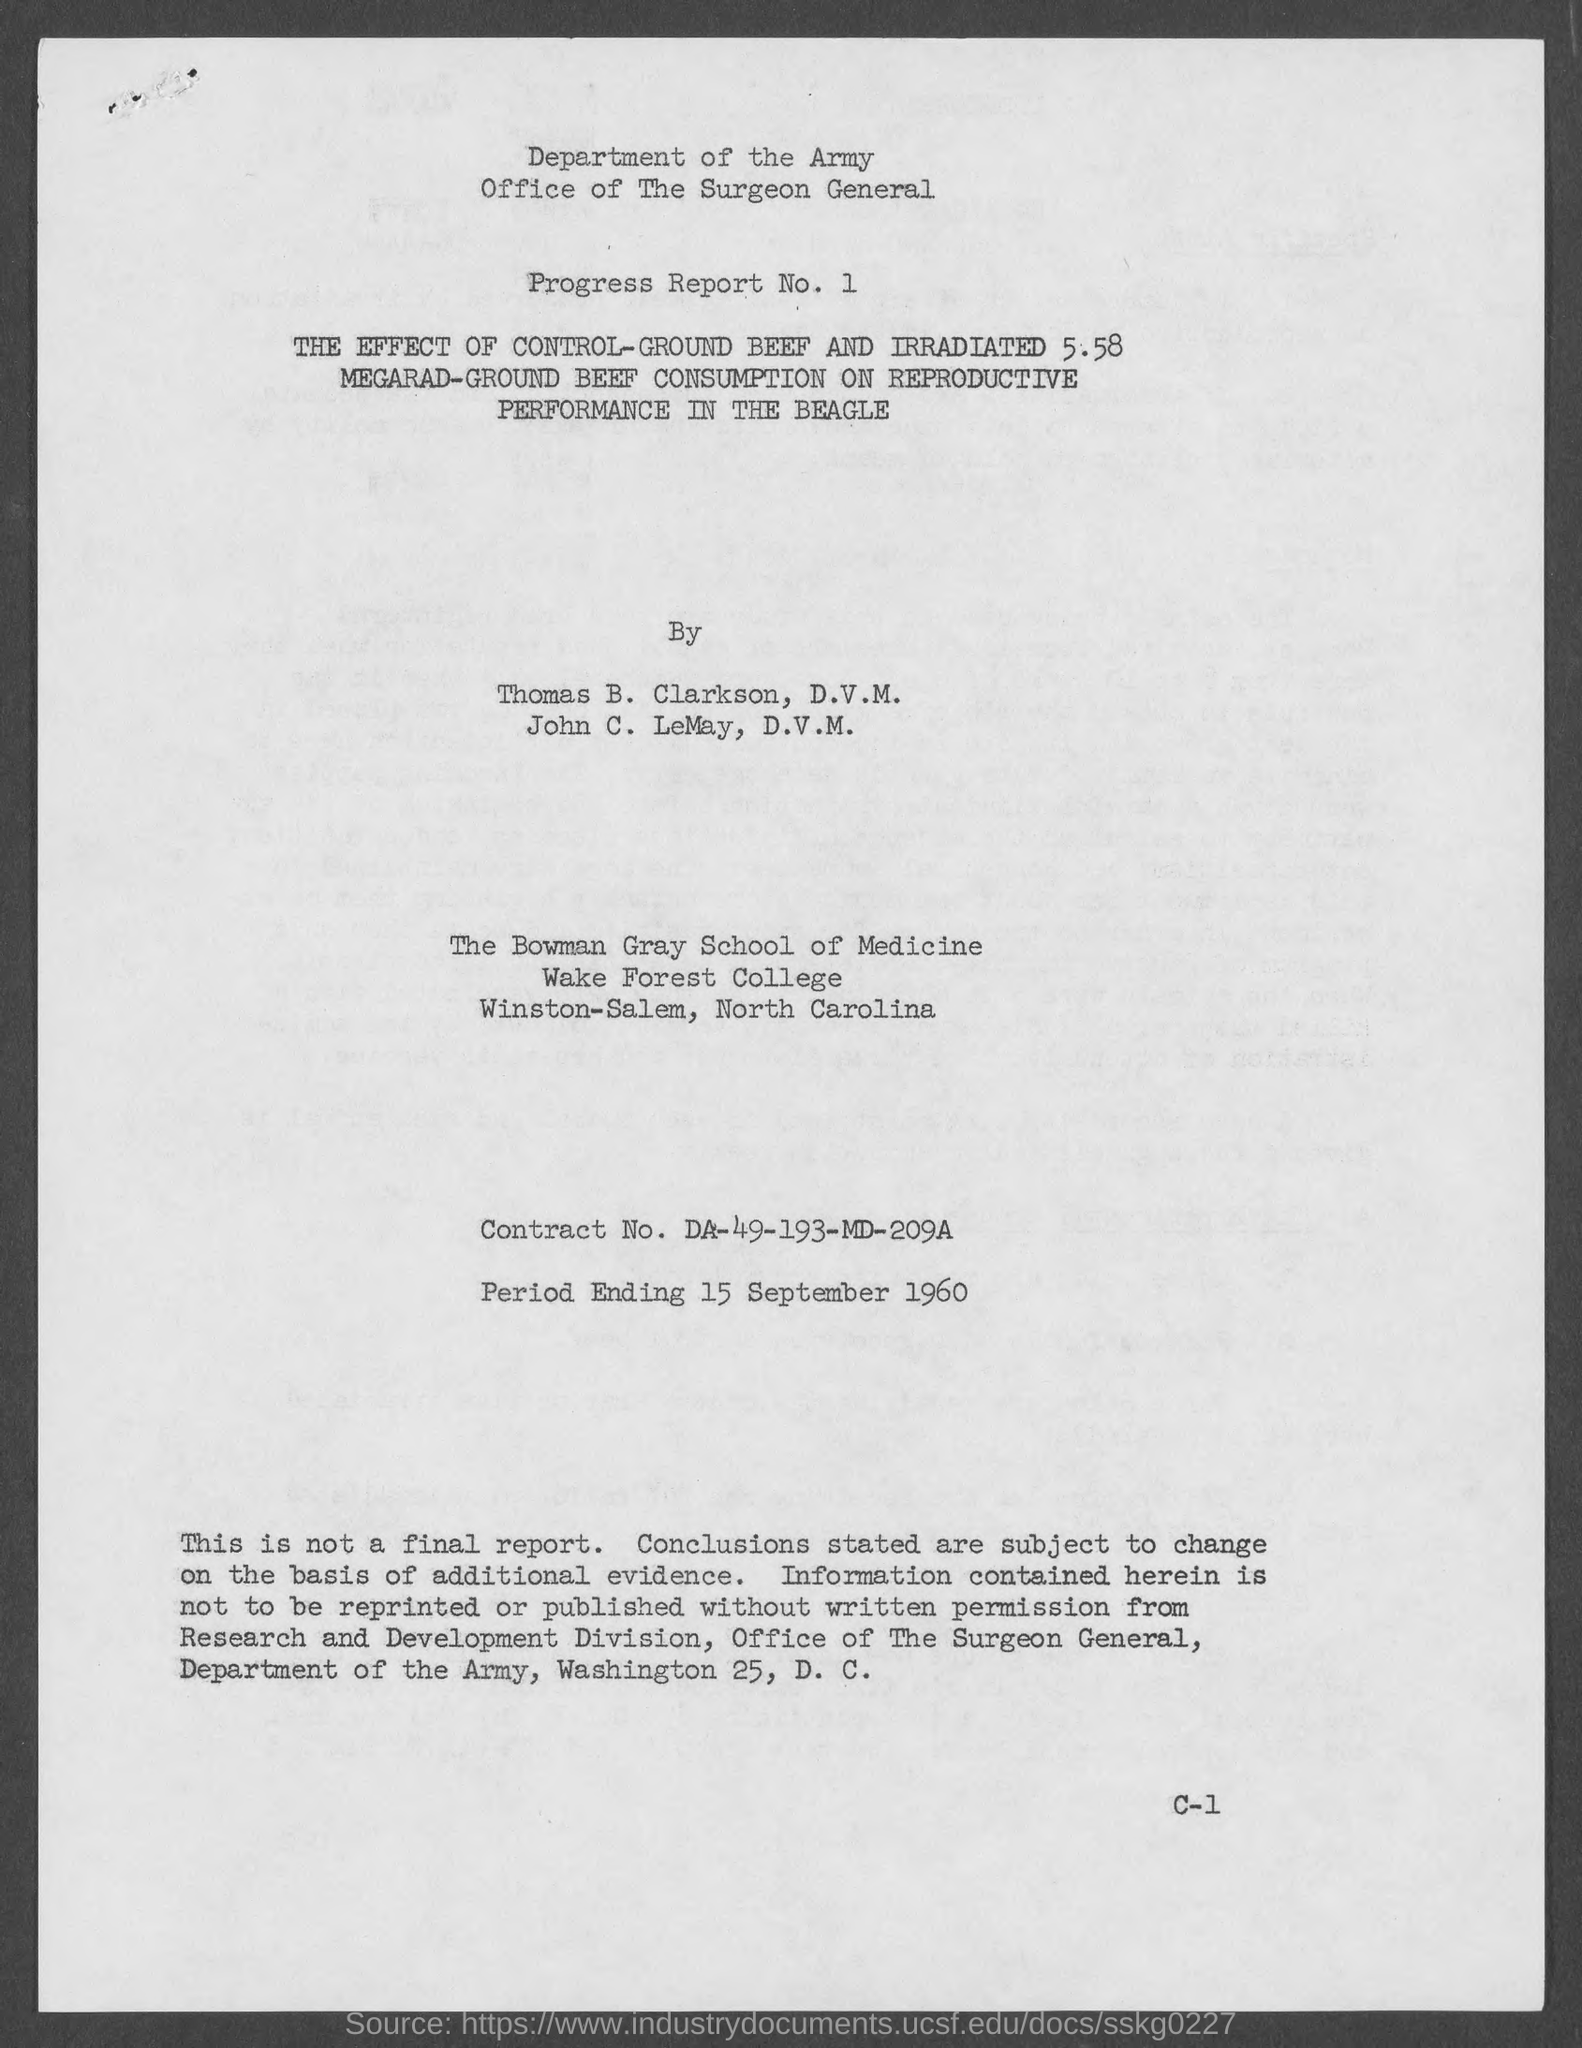What is the Contract No.?
Provide a succinct answer. DA-49-193-MD-209A. Where "The Bowman Gray School of Medicine" is located?
Offer a terse response. Winston-Salem. 